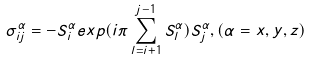<formula> <loc_0><loc_0><loc_500><loc_500>\sigma ^ { \alpha } _ { i j } = - S ^ { \alpha } _ { i } e x p ( i \pi \sum ^ { j - 1 } _ { l = i + 1 } S ^ { \alpha } _ { l } ) S ^ { \alpha } _ { j } , ( \alpha = x , y , z )</formula> 